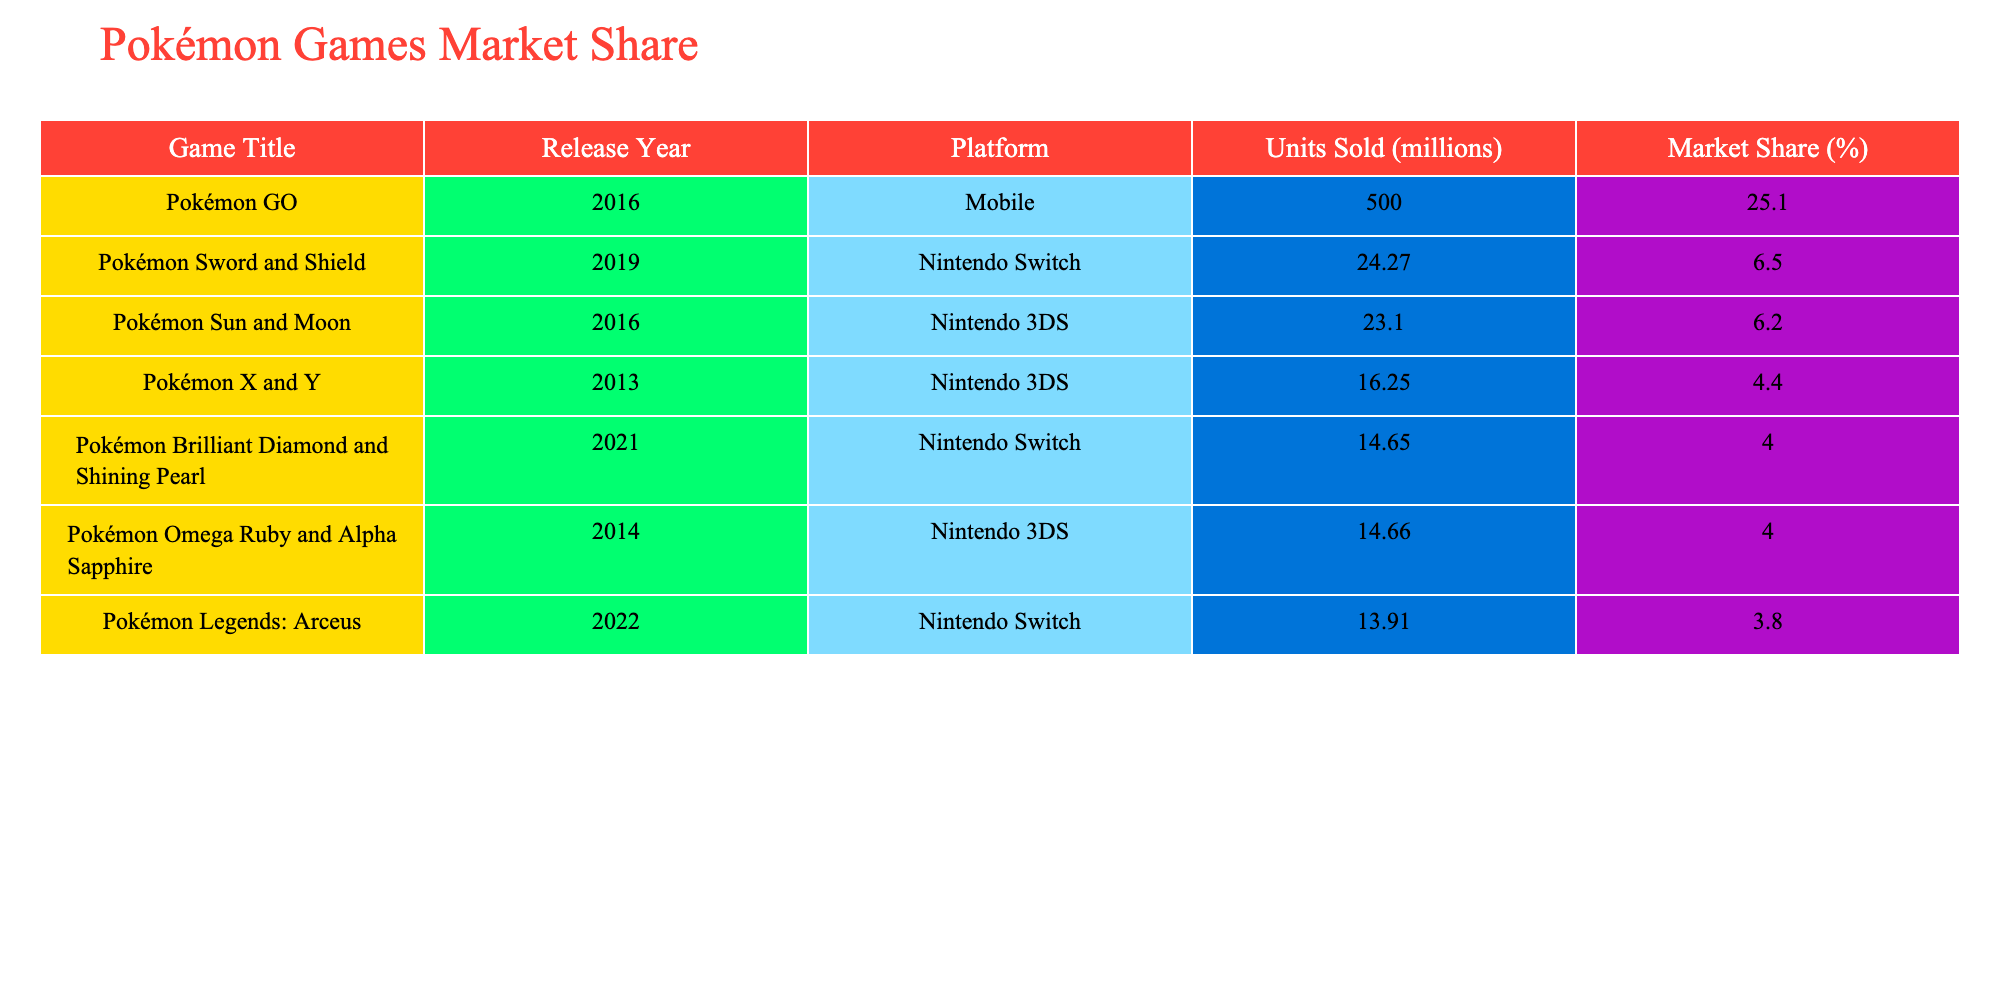What is the highest market share percentage of a Pokémon game in the last decade? The highest market share percentage can be found in the table under the "Market Share (%)" column, and it is for "Pokémon GO" with 25.1%.
Answer: 25.1% Which Pokémon game sold the most units in millions? Looking at the "Units Sold (millions)" column, "Pokémon GO" has the highest sales with 500 million units sold.
Answer: 500 million units What is the average market share of Pokémon games released on the Nintendo Switch? To find the average, we sum the market shares of the Switch games: (6.5 + 3.8 + 4.0 + 4.0) = 18.3%. There are 4 games, so the average is 18.3/4 = 4.575%.
Answer: 4.575% Did "Pokémon Sword and Shield" sell more units than "Pokémon Sun and Moon"? By comparing the "Units Sold" column, "Pokémon Sword and Shield" sold 24.27 million units while "Pokémon Sun and Moon" sold 23.10 million units, so yes, it sold more.
Answer: Yes Which platform has the highest cumulative units sold for Pokémon games? We compare the total units sold for each platform: Nintendo Switch (24.27 + 13.91 + 14.65 = 52.83 million) and Nintendo 3DS (23.10 + 16.25 + 14.66 = 54.01 million) and Mobile (500 million). Mobile is highest with 500 million units.
Answer: Mobile What percentage of the total market share do the Pokémon games on the Nintendo 3DS account for? The market shares for Nintendo 3DS games are 6.2%, 4.4%, and 4.0%, totaling 14.6%. The total market share from the table is 25.1 + 6.5 + 6.2 + 4.4 + 3.8 + 4.0 = 49.0%. Thus, the percentage for 3DS is (14.6/49.0)*100 = 29.8%.
Answer: 29.8% Is "Pokémon Legends: Arceus" one of the top three best-selling Pokémon games? By checking the "Units Sold" against the other titles, "Pokémon Legends: Arceus" with 13.91 million units sold does not place in the top three, as "Pokémon GO," "Pokémon Sword and Shield," and "Pokémon Sun and Moon" have higher sales.
Answer: No What is the difference in units sold between "Pokémon Brilliant Diamond and Shining Pearl" and "Pokémon Omega Ruby and Alpha Sapphire"? "Pokémon Brilliant Diamond and Shining Pearl" sold 14.65 million, and "Pokémon Omega Ruby and Alpha Sapphire" sold 14.66 million. The difference is 14.66 - 14.65 = 0.01 million units.
Answer: 0.01 million units 